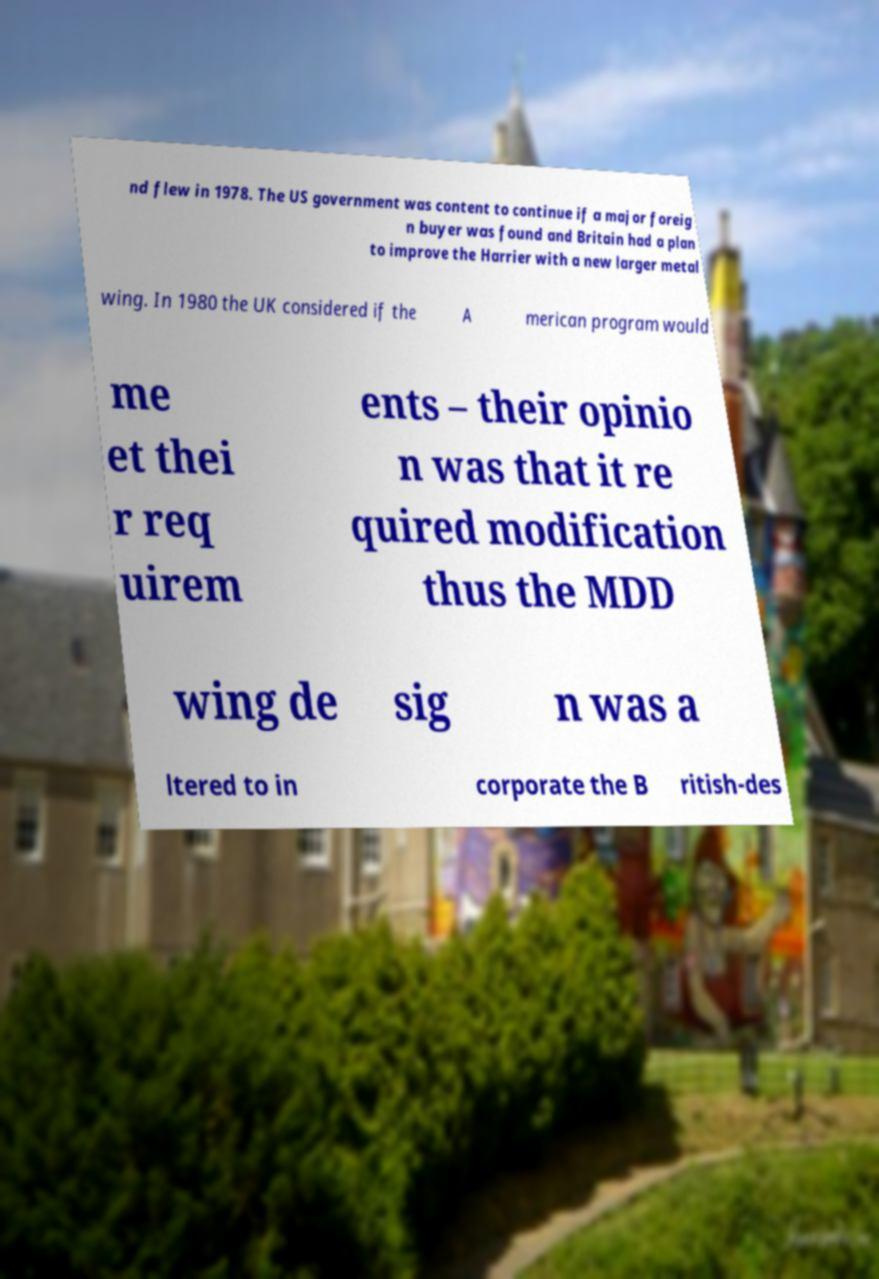For documentation purposes, I need the text within this image transcribed. Could you provide that? nd flew in 1978. The US government was content to continue if a major foreig n buyer was found and Britain had a plan to improve the Harrier with a new larger metal wing. In 1980 the UK considered if the A merican program would me et thei r req uirem ents – their opinio n was that it re quired modification thus the MDD wing de sig n was a ltered to in corporate the B ritish-des 